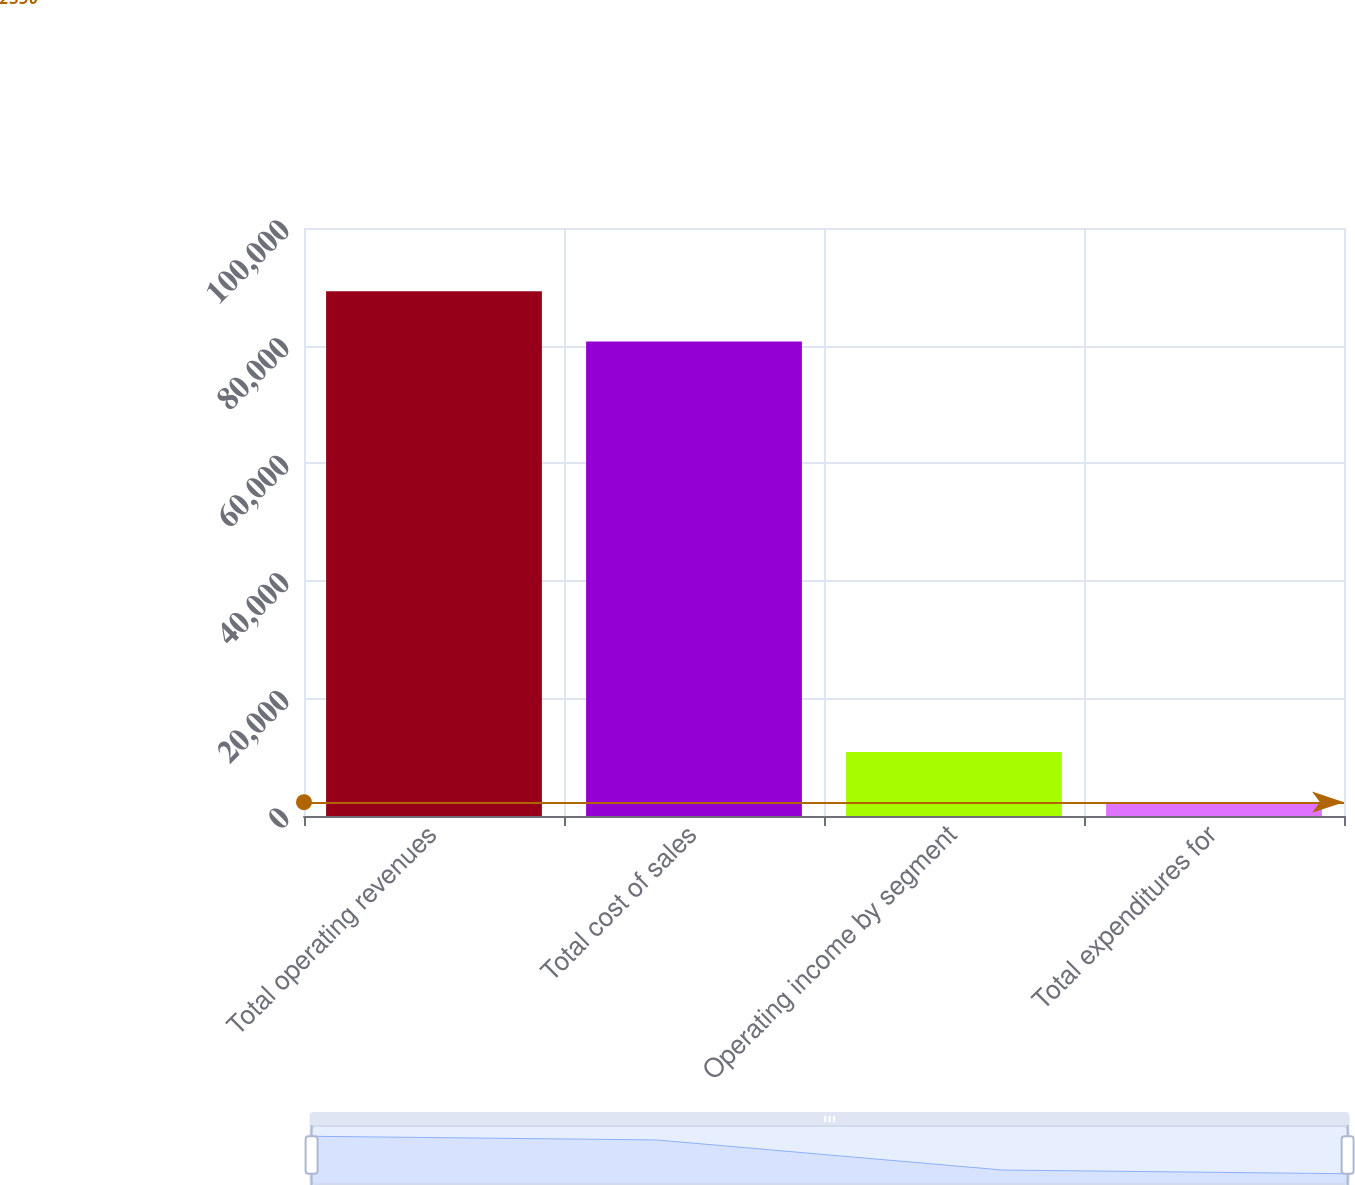<chart> <loc_0><loc_0><loc_500><loc_500><bar_chart><fcel>Total operating revenues<fcel>Total cost of sales<fcel>Operating income by segment<fcel>Total expenditures for<nl><fcel>89234.4<fcel>80689<fcel>10895.4<fcel>2350<nl></chart> 